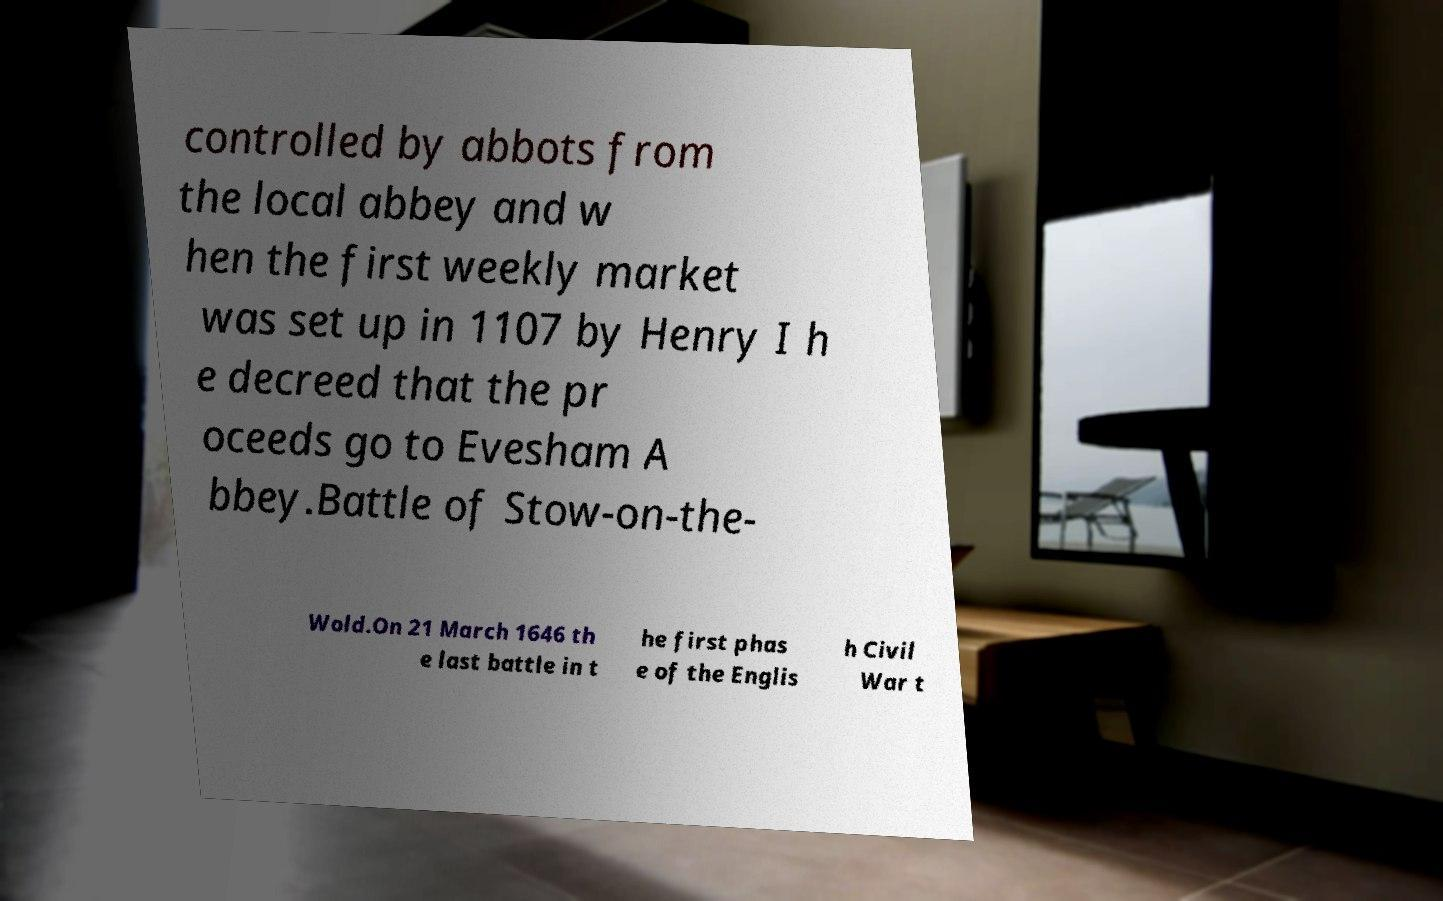For documentation purposes, I need the text within this image transcribed. Could you provide that? controlled by abbots from the local abbey and w hen the first weekly market was set up in 1107 by Henry I h e decreed that the pr oceeds go to Evesham A bbey.Battle of Stow-on-the- Wold.On 21 March 1646 th e last battle in t he first phas e of the Englis h Civil War t 